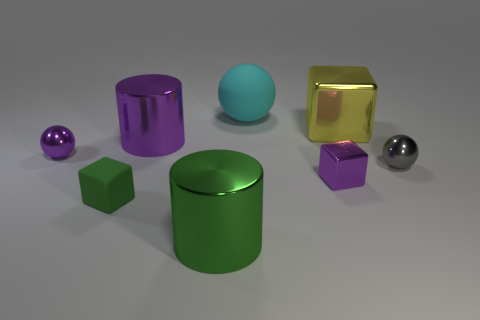Add 1 tiny purple cubes. How many objects exist? 9 Subtract all yellow blocks. How many blocks are left? 2 Subtract all rubber balls. How many balls are left? 2 Subtract 0 yellow spheres. How many objects are left? 8 Subtract all cylinders. How many objects are left? 6 Subtract 1 blocks. How many blocks are left? 2 Subtract all red cylinders. Subtract all brown spheres. How many cylinders are left? 2 Subtract all red cylinders. How many green balls are left? 0 Subtract all big matte cylinders. Subtract all small purple metal things. How many objects are left? 6 Add 3 large green objects. How many large green objects are left? 4 